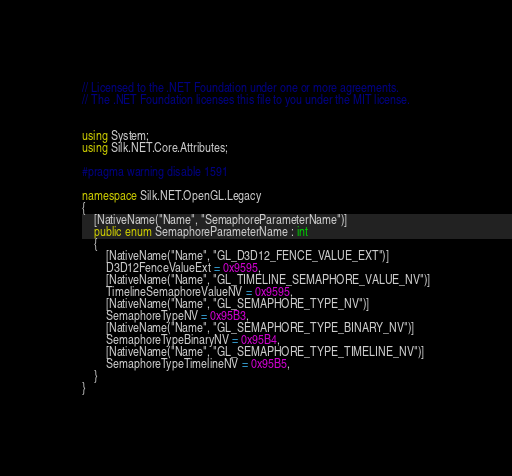Convert code to text. <code><loc_0><loc_0><loc_500><loc_500><_C#_>// Licensed to the .NET Foundation under one or more agreements.
// The .NET Foundation licenses this file to you under the MIT license.


using System;
using Silk.NET.Core.Attributes;

#pragma warning disable 1591

namespace Silk.NET.OpenGL.Legacy
{
    [NativeName("Name", "SemaphoreParameterName")]
    public enum SemaphoreParameterName : int
    {
        [NativeName("Name", "GL_D3D12_FENCE_VALUE_EXT")]
        D3D12FenceValueExt = 0x9595,
        [NativeName("Name", "GL_TIMELINE_SEMAPHORE_VALUE_NV")]
        TimelineSemaphoreValueNV = 0x9595,
        [NativeName("Name", "GL_SEMAPHORE_TYPE_NV")]
        SemaphoreTypeNV = 0x95B3,
        [NativeName("Name", "GL_SEMAPHORE_TYPE_BINARY_NV")]
        SemaphoreTypeBinaryNV = 0x95B4,
        [NativeName("Name", "GL_SEMAPHORE_TYPE_TIMELINE_NV")]
        SemaphoreTypeTimelineNV = 0x95B5,
    }
}
</code> 